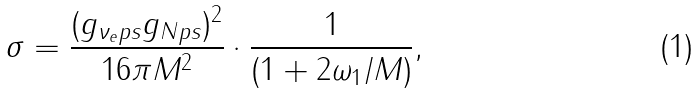<formula> <loc_0><loc_0><loc_500><loc_500>\sigma = \frac { ( g _ { \nu _ { e } p s } g _ { N p s } ) ^ { 2 } } { 1 6 \pi M ^ { 2 } } \cdot \frac { 1 } { ( 1 + 2 \omega _ { 1 } / M ) } ,</formula> 